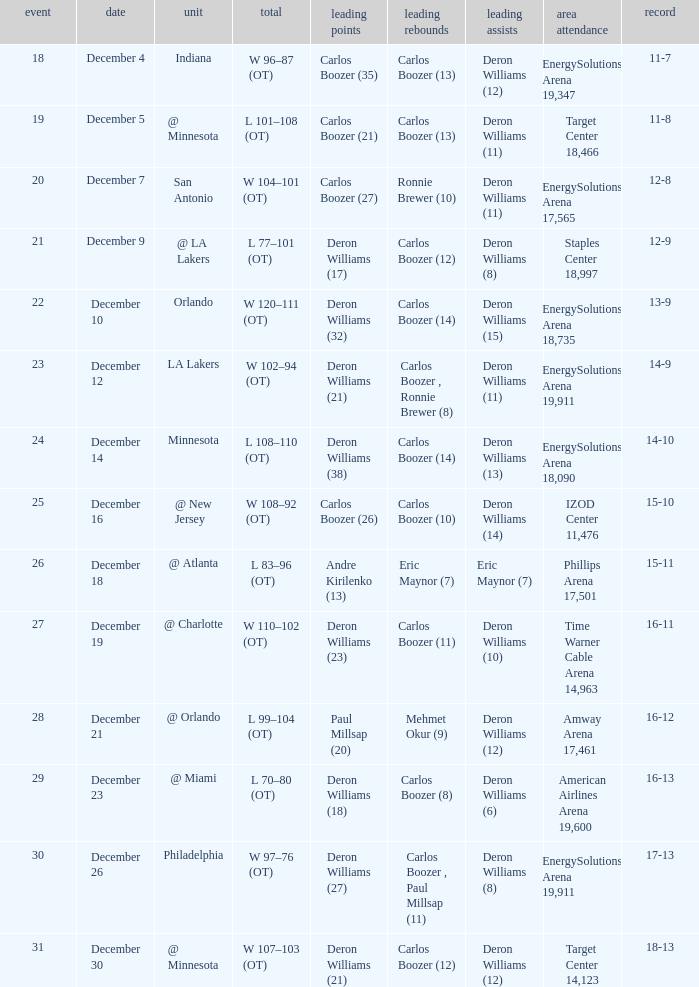Help me parse the entirety of this table. {'header': ['event', 'date', 'unit', 'total', 'leading points', 'leading rebounds', 'leading assists', 'area attendance', 'record'], 'rows': [['18', 'December 4', 'Indiana', 'W 96–87 (OT)', 'Carlos Boozer (35)', 'Carlos Boozer (13)', 'Deron Williams (12)', 'EnergySolutions Arena 19,347', '11-7'], ['19', 'December 5', '@ Minnesota', 'L 101–108 (OT)', 'Carlos Boozer (21)', 'Carlos Boozer (13)', 'Deron Williams (11)', 'Target Center 18,466', '11-8'], ['20', 'December 7', 'San Antonio', 'W 104–101 (OT)', 'Carlos Boozer (27)', 'Ronnie Brewer (10)', 'Deron Williams (11)', 'EnergySolutions Arena 17,565', '12-8'], ['21', 'December 9', '@ LA Lakers', 'L 77–101 (OT)', 'Deron Williams (17)', 'Carlos Boozer (12)', 'Deron Williams (8)', 'Staples Center 18,997', '12-9'], ['22', 'December 10', 'Orlando', 'W 120–111 (OT)', 'Deron Williams (32)', 'Carlos Boozer (14)', 'Deron Williams (15)', 'EnergySolutions Arena 18,735', '13-9'], ['23', 'December 12', 'LA Lakers', 'W 102–94 (OT)', 'Deron Williams (21)', 'Carlos Boozer , Ronnie Brewer (8)', 'Deron Williams (11)', 'EnergySolutions Arena 19,911', '14-9'], ['24', 'December 14', 'Minnesota', 'L 108–110 (OT)', 'Deron Williams (38)', 'Carlos Boozer (14)', 'Deron Williams (13)', 'EnergySolutions Arena 18,090', '14-10'], ['25', 'December 16', '@ New Jersey', 'W 108–92 (OT)', 'Carlos Boozer (26)', 'Carlos Boozer (10)', 'Deron Williams (14)', 'IZOD Center 11,476', '15-10'], ['26', 'December 18', '@ Atlanta', 'L 83–96 (OT)', 'Andre Kirilenko (13)', 'Eric Maynor (7)', 'Eric Maynor (7)', 'Phillips Arena 17,501', '15-11'], ['27', 'December 19', '@ Charlotte', 'W 110–102 (OT)', 'Deron Williams (23)', 'Carlos Boozer (11)', 'Deron Williams (10)', 'Time Warner Cable Arena 14,963', '16-11'], ['28', 'December 21', '@ Orlando', 'L 99–104 (OT)', 'Paul Millsap (20)', 'Mehmet Okur (9)', 'Deron Williams (12)', 'Amway Arena 17,461', '16-12'], ['29', 'December 23', '@ Miami', 'L 70–80 (OT)', 'Deron Williams (18)', 'Carlos Boozer (8)', 'Deron Williams (6)', 'American Airlines Arena 19,600', '16-13'], ['30', 'December 26', 'Philadelphia', 'W 97–76 (OT)', 'Deron Williams (27)', 'Carlos Boozer , Paul Millsap (11)', 'Deron Williams (8)', 'EnergySolutions Arena 19,911', '17-13'], ['31', 'December 30', '@ Minnesota', 'W 107–103 (OT)', 'Deron Williams (21)', 'Carlos Boozer (12)', 'Deron Williams (12)', 'Target Center 14,123', '18-13']]} How many different high rebound results are there for the game number 26? 1.0. 